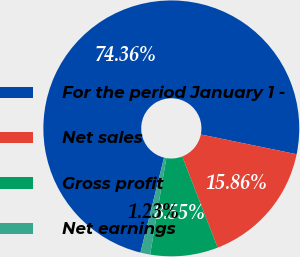<chart> <loc_0><loc_0><loc_500><loc_500><pie_chart><fcel>For the period January 1 -<fcel>Net sales<fcel>Gross profit<fcel>Net earnings<nl><fcel>74.36%<fcel>15.86%<fcel>8.55%<fcel>1.23%<nl></chart> 